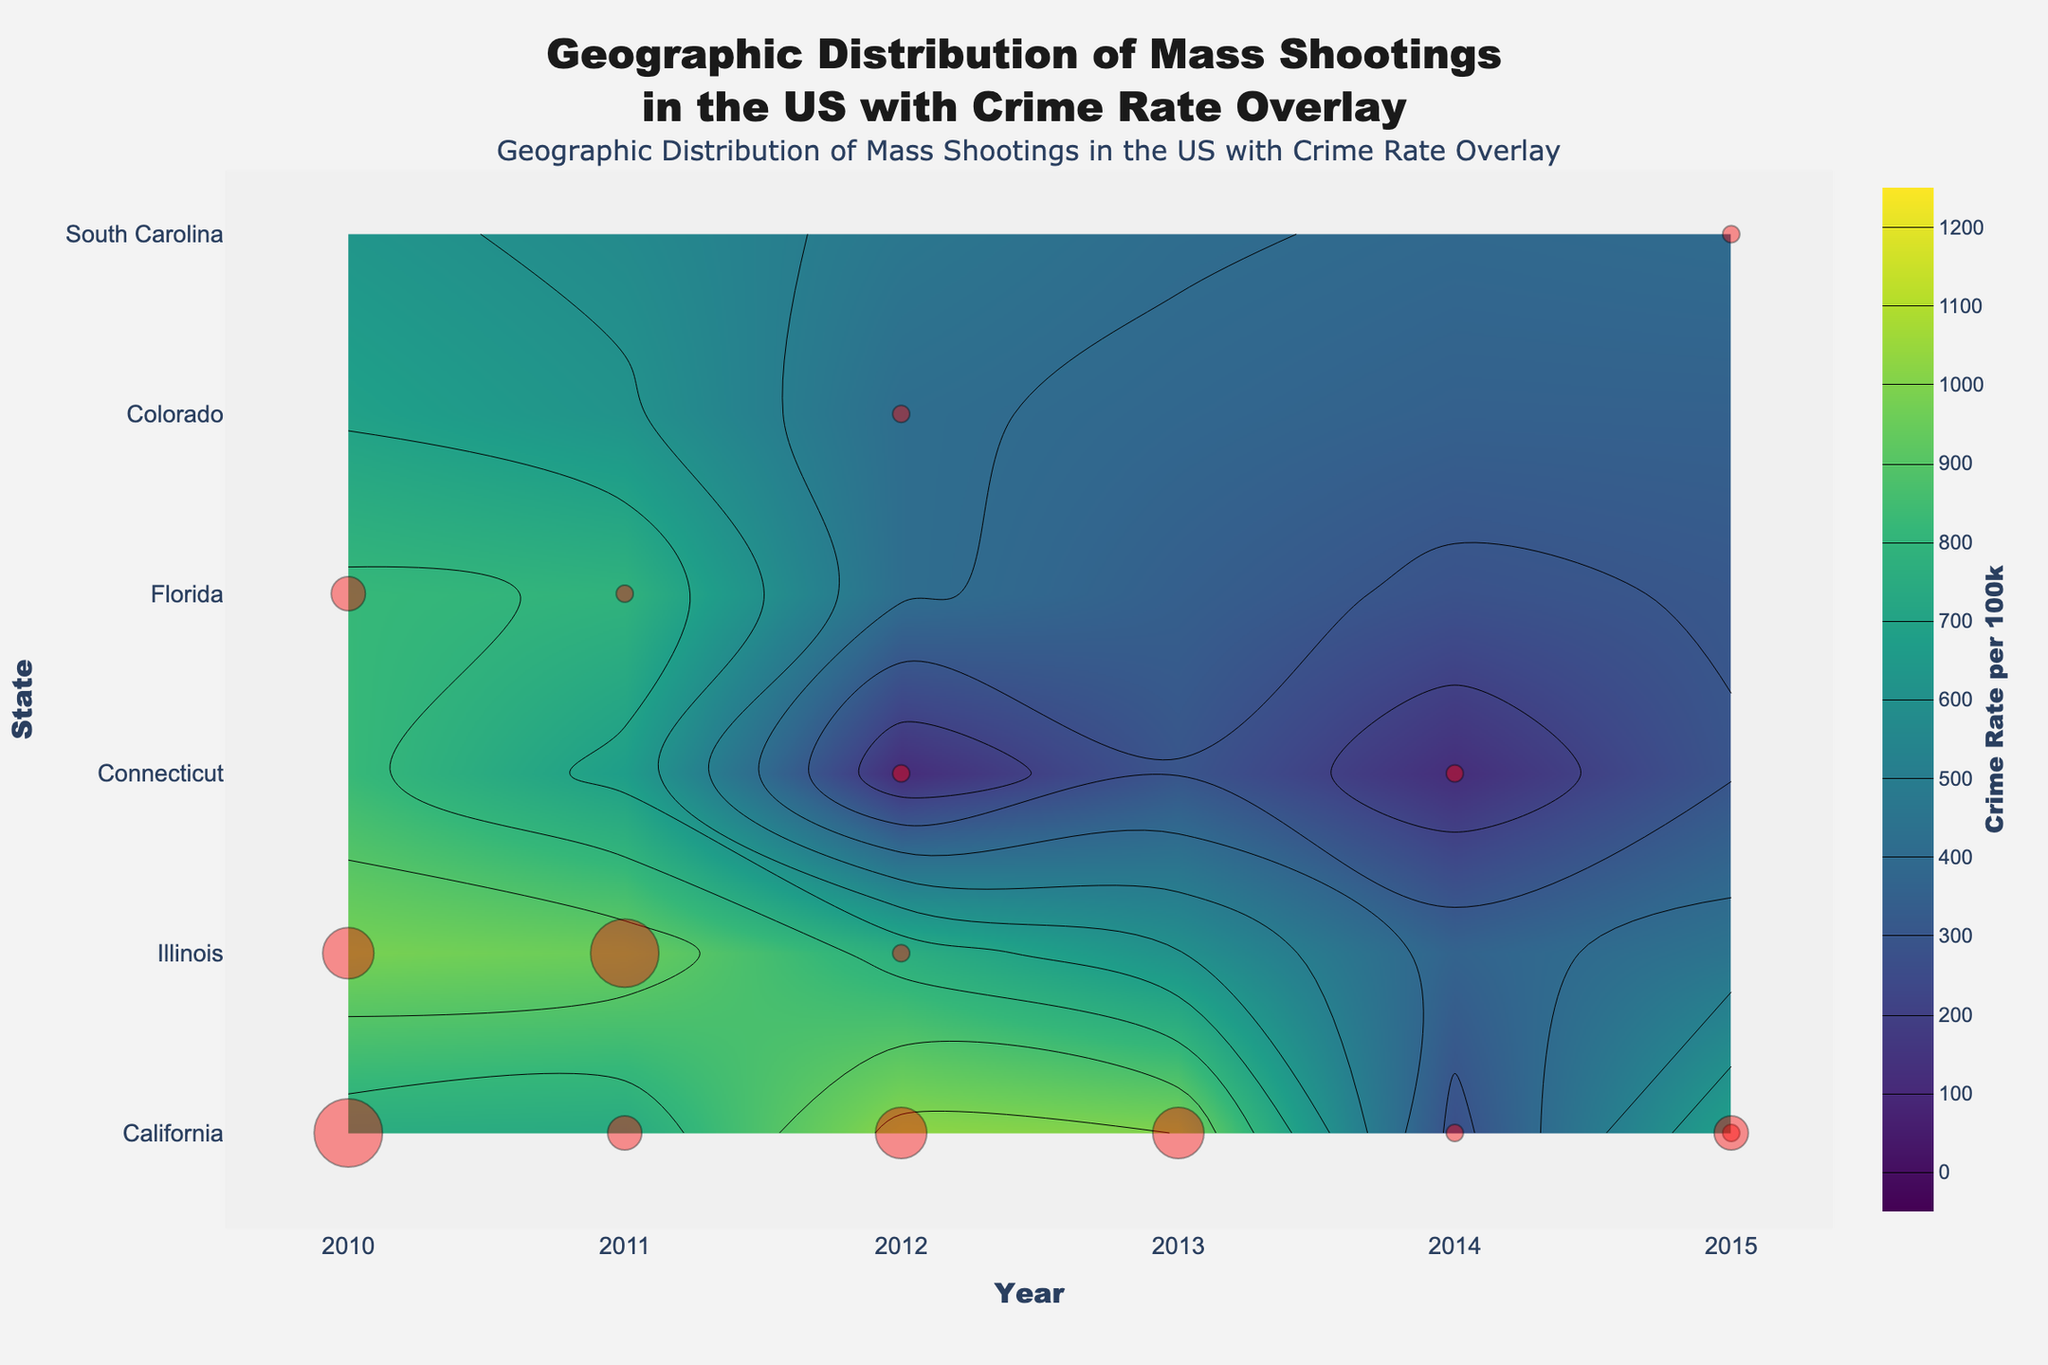What is the title of the figure? The title is usually present at the top of the figure, and in this case, it combines geographic distribution with crime rate overlay related to mass shootings in the US.
Answer: Geographic Distribution of Mass Shootings in the US with Crime Rate Overlay Which state shows multiple mass shooting incidents over the years? By observing the scatter markers, one can see that California has multiple incidents marked across different years.
Answer: California What is the size of the markers in the plot, and what do they represent? The size of the markers varies and is proportional to the number of mass shooting incidents. Larger markers indicate more incidents.
Answer: Proportional to incidents Which state had the highest crime rate in any given year and what was that rate? Looking at the contour shades, San Bernardino in California shows the highest crime rate, especially the dark region in 2012.
Answer: San Bernardino, 1027.1 per 100k In which year did Chicago have the highest number of mass shooting incidents? By comparing the marker sizes over different years, 2011 shows a larger marker indicating the highest incident count.
Answer: 2011 How does the crime rate in Los Angeles change from 2010 to 2011? Checking the contour color for Los Angeles, the crime rate reduces from a lighter to a slightly darker shade, indicating a decrease.
Answer: Decreases Compare the number of mass shooting incidents in San Bernardino and Aurora. Which has more? Comparing the marker sizes for both cities over the years, San Bernardino has more prominent markers.
Answer: San Bernardino Identify a year where a city outside California had a significant number of mass shooting incidents. Observing the markers outside California, Chicago in 2011 and Charleston in 2015 have significant markers.
Answer: Chicago 2011, Charleston 2015 Which city in California had a mass shooting incident in 2014? Checking the marker labeled for 2014 within California, Isla Vista shows an incident.
Answer: Isla Vista In 2012, which state had a city named Newtown with notable mass shooting incidents? Referring to the markers and their corresponding text in 2012, Connecticut has Newtown listed.
Answer: Connecticut 